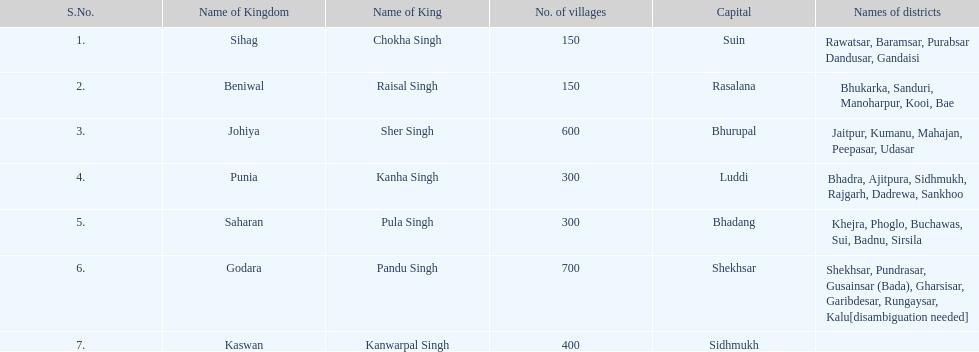How many districts does punia have? 6. 